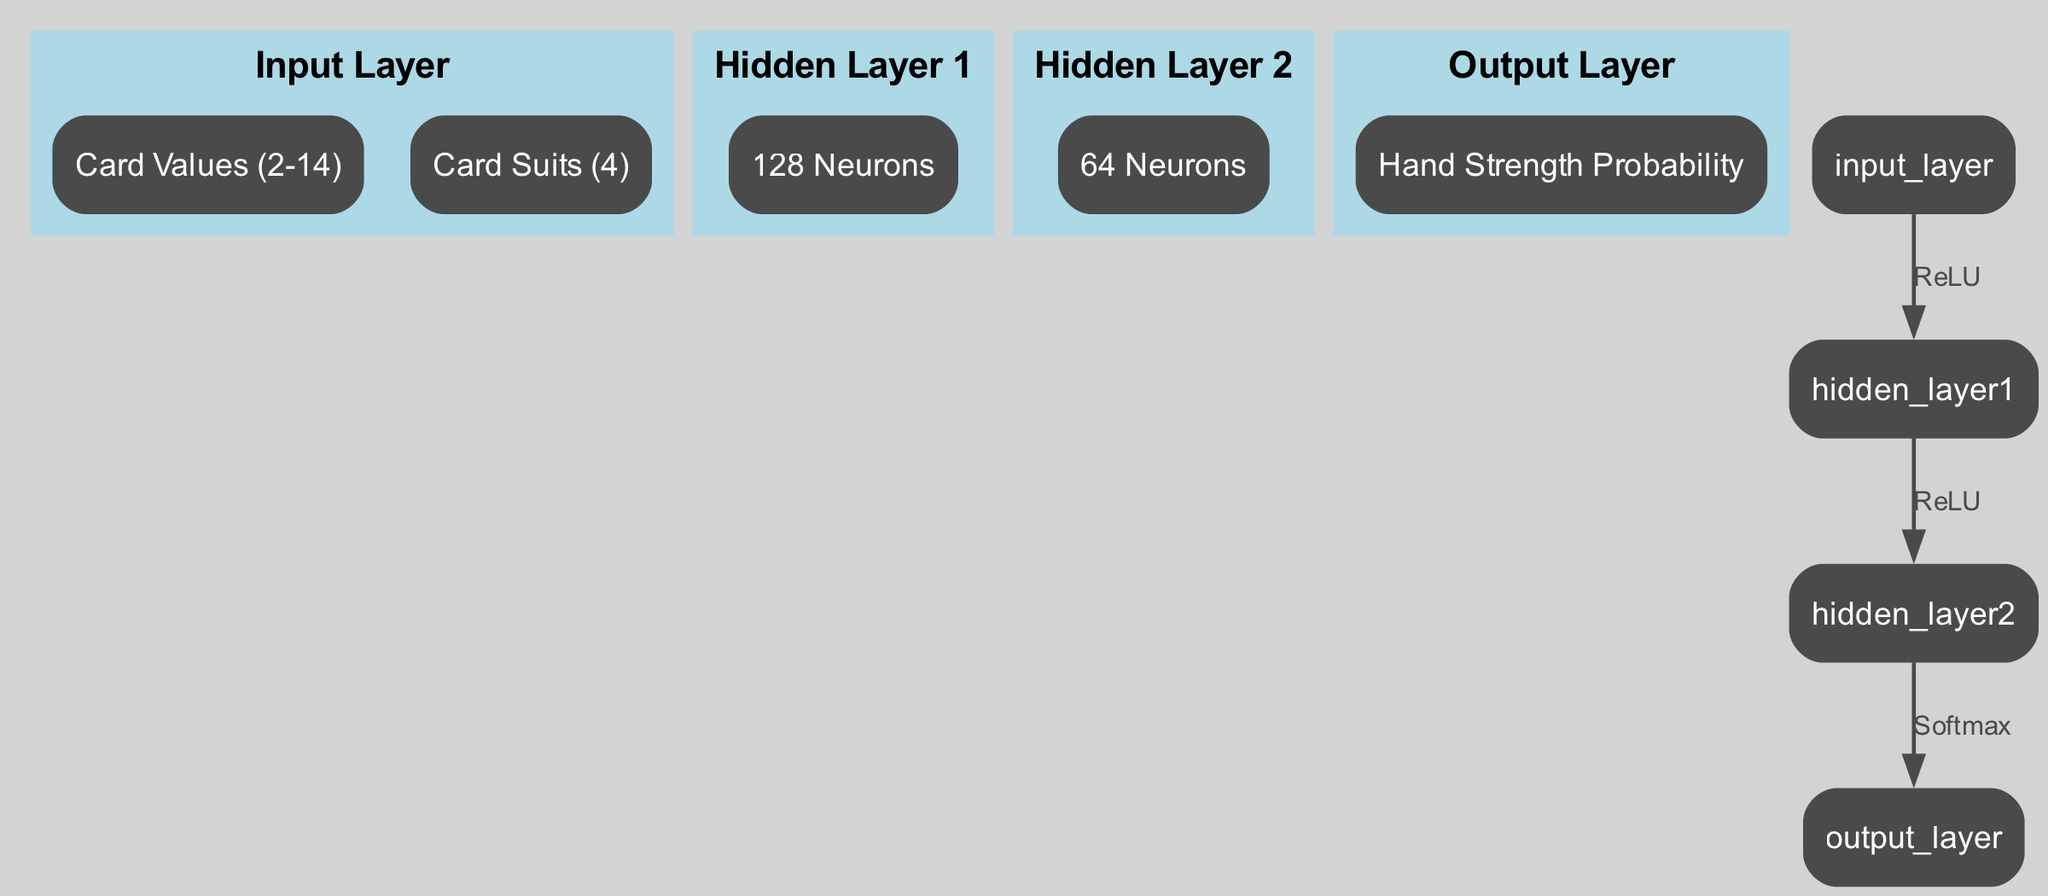What does the output layer represent? The output layer is labeled "Hand Strength Probability," indicating that it represents the predicted probabilities of different poker hand strengths.
Answer: Hand Strength Probability How many neurons are in Hidden Layer 1? Hidden Layer 1 is labeled with "128 Neurons," which specifies the exact number of neurons present in that layer.
Answer: 128 Neurons What is the activation function used between the input layer and Hidden Layer 1? The edge connecting the input layer to Hidden Layer 1 is labeled "ReLU," indicating that the activation function used for the transformation is Rectified Linear Unit.
Answer: ReLU How many layers are present in total in this neural network architecture? There are four layers in total: one input layer, two hidden layers, and one output layer, counting them all together.
Answer: Four What connects Hidden Layer 2 to the output layer? The connection from Hidden Layer 2 to the output layer is labeled "Softmax," meaning that the Softmax function is applied to generate the output probabilities.
Answer: Softmax What is the role of the hidden layers in this architecture? Hidden layers process the input data through transformations, using activation functions (ReLU) to learn complex patterns in the poker hand strength data.
Answer: Transformations What do the card values in the input layer represent? The card values in the input layer range from "2-14," which symbolizes the possible values of the cards in a poker hand.
Answer: Card Values (2-14) Which layer has fewer neurons, and how many does it have? Hidden Layer 2 has fewer neurons than Hidden Layer 1, with "64 Neurons" indicating the specific number in that layer.
Answer: 64 Neurons How does the data flow through this neural network? The data flows from the input layer to Hidden Layer 1, then to Hidden Layer 2, and finally to the output layer, following the connections along the edges of the diagram.
Answer: Input to Hidden Layer 1 to Hidden Layer 2 to Output Layer 